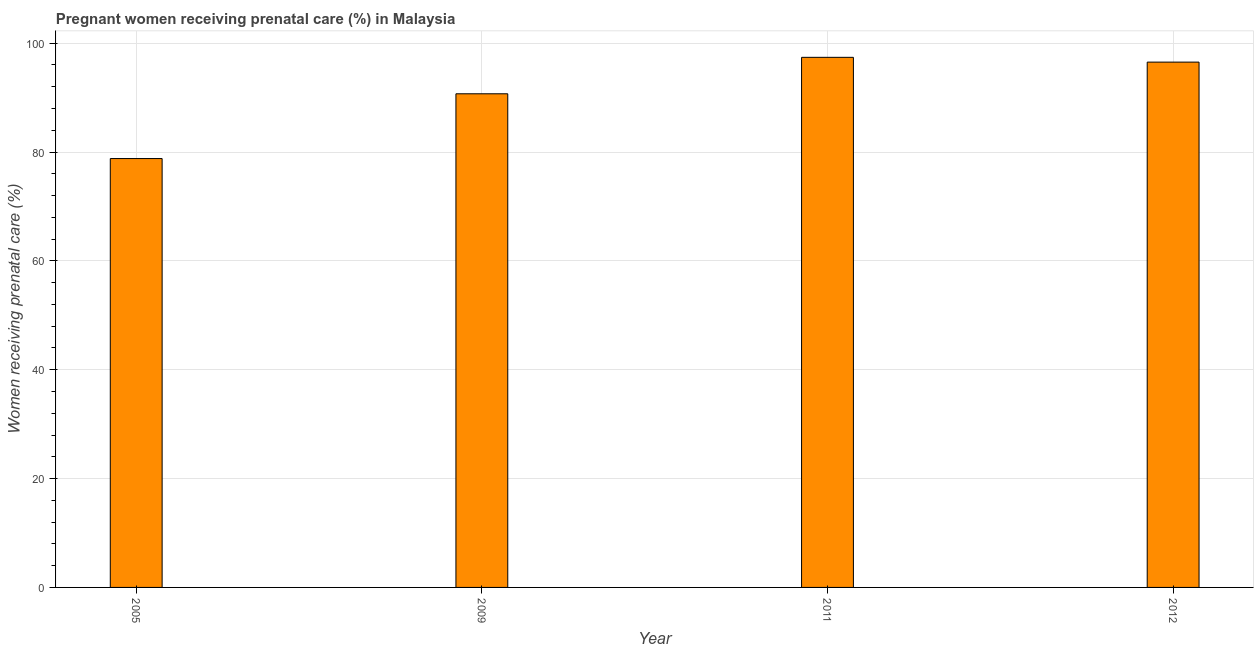What is the title of the graph?
Your answer should be compact. Pregnant women receiving prenatal care (%) in Malaysia. What is the label or title of the Y-axis?
Provide a short and direct response. Women receiving prenatal care (%). What is the percentage of pregnant women receiving prenatal care in 2005?
Your response must be concise. 78.8. Across all years, what is the maximum percentage of pregnant women receiving prenatal care?
Ensure brevity in your answer.  97.4. Across all years, what is the minimum percentage of pregnant women receiving prenatal care?
Provide a succinct answer. 78.8. What is the sum of the percentage of pregnant women receiving prenatal care?
Give a very brief answer. 363.42. What is the average percentage of pregnant women receiving prenatal care per year?
Ensure brevity in your answer.  90.86. What is the median percentage of pregnant women receiving prenatal care?
Offer a terse response. 93.61. In how many years, is the percentage of pregnant women receiving prenatal care greater than 92 %?
Ensure brevity in your answer.  2. Do a majority of the years between 2009 and 2011 (inclusive) have percentage of pregnant women receiving prenatal care greater than 40 %?
Your response must be concise. Yes. What is the ratio of the percentage of pregnant women receiving prenatal care in 2005 to that in 2009?
Your response must be concise. 0.87. What is the difference between the highest and the lowest percentage of pregnant women receiving prenatal care?
Ensure brevity in your answer.  18.6. How many years are there in the graph?
Your response must be concise. 4. What is the difference between two consecutive major ticks on the Y-axis?
Make the answer very short. 20. What is the Women receiving prenatal care (%) of 2005?
Keep it short and to the point. 78.8. What is the Women receiving prenatal care (%) in 2009?
Make the answer very short. 90.7. What is the Women receiving prenatal care (%) of 2011?
Provide a succinct answer. 97.4. What is the Women receiving prenatal care (%) of 2012?
Your answer should be compact. 96.52. What is the difference between the Women receiving prenatal care (%) in 2005 and 2011?
Your answer should be compact. -18.6. What is the difference between the Women receiving prenatal care (%) in 2005 and 2012?
Offer a terse response. -17.72. What is the difference between the Women receiving prenatal care (%) in 2009 and 2012?
Provide a succinct answer. -5.82. What is the ratio of the Women receiving prenatal care (%) in 2005 to that in 2009?
Ensure brevity in your answer.  0.87. What is the ratio of the Women receiving prenatal care (%) in 2005 to that in 2011?
Your answer should be very brief. 0.81. What is the ratio of the Women receiving prenatal care (%) in 2005 to that in 2012?
Keep it short and to the point. 0.82. What is the ratio of the Women receiving prenatal care (%) in 2011 to that in 2012?
Make the answer very short. 1.01. 